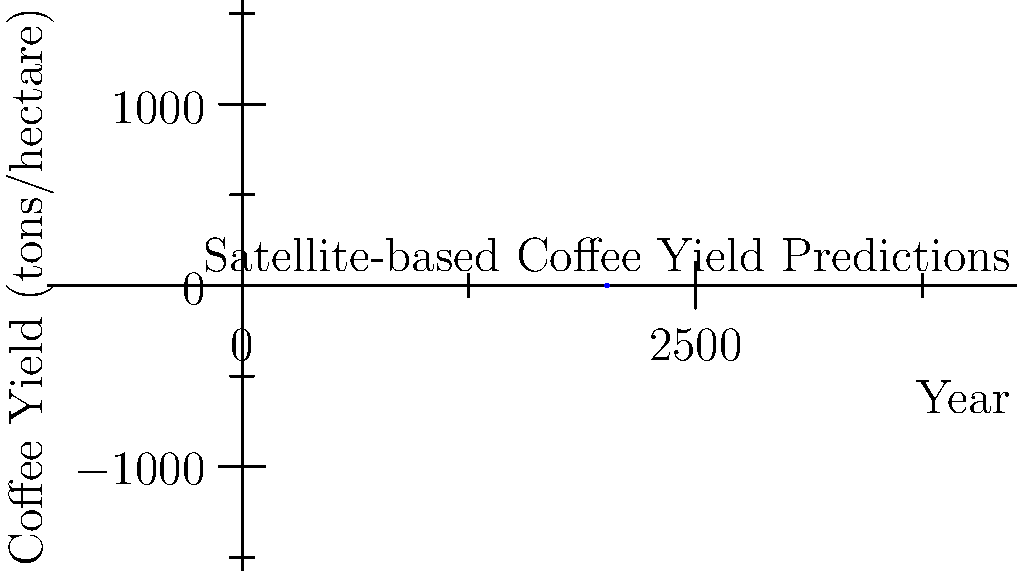Based on the satellite imagery analysis shown in the graph, what is the predicted coffee yield in Timor-Leste for 2016 if the trend continues? Assume a linear relationship between the years 2014 and 2015. To predict the coffee yield for 2016, we need to follow these steps:

1. Identify the trend: The graph shows an overall increasing trend in coffee yields from 2010 to 2015.

2. Focus on the most recent data: We'll use the linear relationship between 2014 and 2015 to predict 2016.

3. Calculate the rate of change:
   Yield in 2014: 0.85 tons/hectare
   Yield in 2015: 1.0 tons/hectare
   Change in yield: 1.0 - 0.85 = 0.15 tons/hectare
   Time period: 1 year
   Rate of change: 0.15 tons/hectare/year

4. Apply the rate of change to predict 2016:
   Predicted yield for 2016 = 2015 yield + rate of change
   $$ \text{Yield}_{2016} = 1.0 + 0.15 = 1.15 \text{ tons/hectare} $$

Therefore, if the trend continues, the predicted coffee yield for 2016 in Timor-Leste would be 1.15 tons/hectare.
Answer: 1.15 tons/hectare 